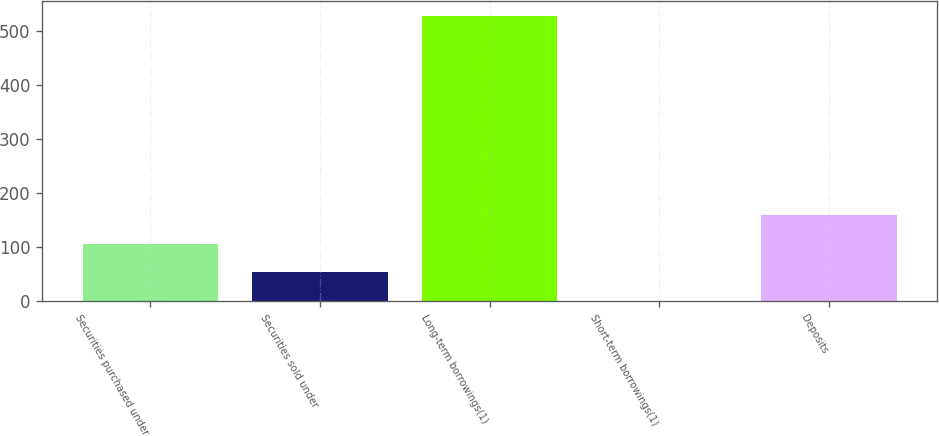Convert chart. <chart><loc_0><loc_0><loc_500><loc_500><bar_chart><fcel>Securities purchased under<fcel>Securities sold under<fcel>Long-term borrowings(1)<fcel>Short-term borrowings(1)<fcel>Deposits<nl><fcel>106.4<fcel>53.7<fcel>528<fcel>1<fcel>159.1<nl></chart> 